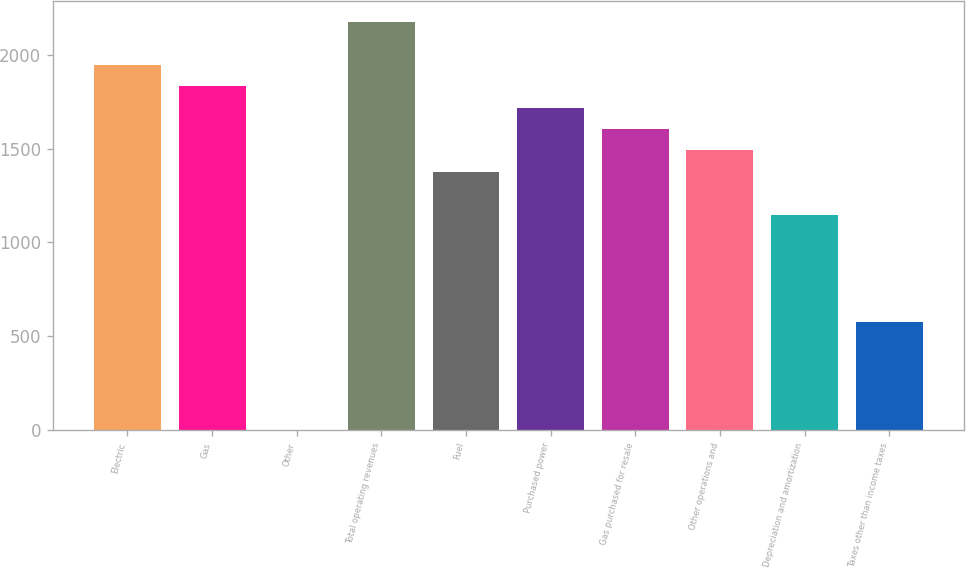<chart> <loc_0><loc_0><loc_500><loc_500><bar_chart><fcel>Electric<fcel>Gas<fcel>Other<fcel>Total operating revenues<fcel>Fuel<fcel>Purchased power<fcel>Gas purchased for resale<fcel>Other operations and<fcel>Depreciation and amortization<fcel>Taxes other than income taxes<nl><fcel>1949.2<fcel>1834.6<fcel>1<fcel>2178.4<fcel>1376.2<fcel>1720<fcel>1605.4<fcel>1490.8<fcel>1147<fcel>574<nl></chart> 